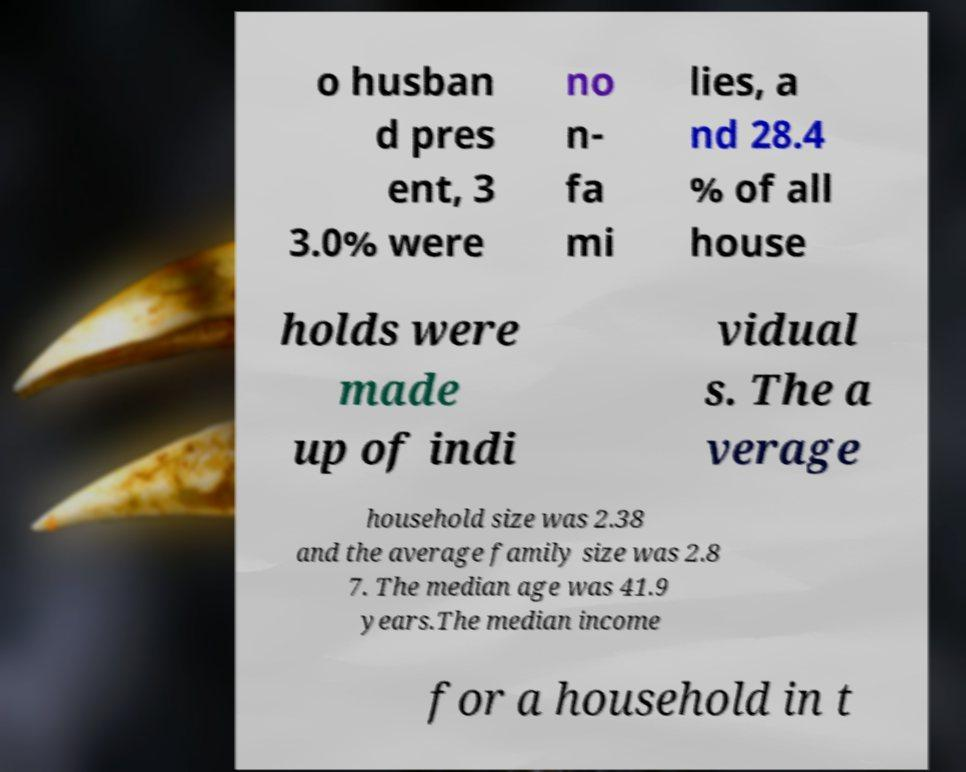For documentation purposes, I need the text within this image transcribed. Could you provide that? o husban d pres ent, 3 3.0% were no n- fa mi lies, a nd 28.4 % of all house holds were made up of indi vidual s. The a verage household size was 2.38 and the average family size was 2.8 7. The median age was 41.9 years.The median income for a household in t 